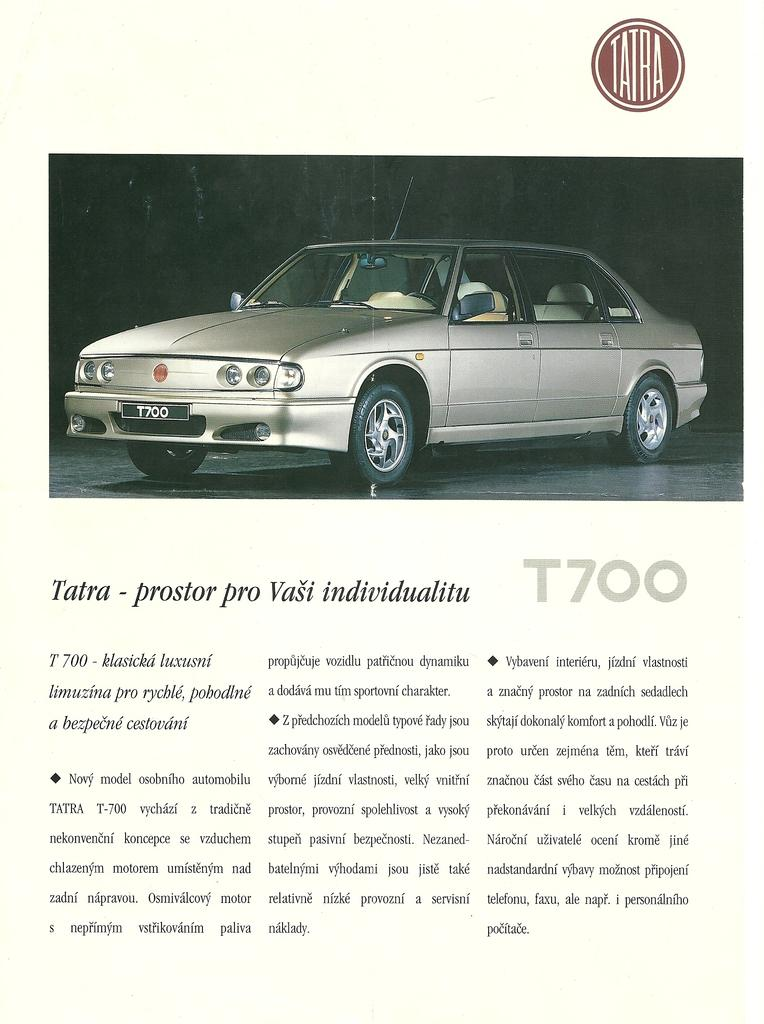What is present on the poster in the image? The poster contains text and images. Can you describe the content of the poster in more detail? Unfortunately, the specific content of the poster cannot be determined from the provided facts. How does the poster push the person away in the image? The poster does not push anyone away in the image; it is a static object containing text and images. 